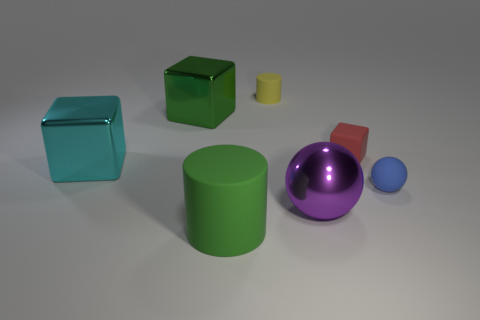Subtract all shiny blocks. How many blocks are left? 1 Add 3 small blue metal spheres. How many objects exist? 10 Subtract all balls. How many objects are left? 5 Subtract 0 brown cylinders. How many objects are left? 7 Subtract all yellow blocks. Subtract all green cylinders. How many blocks are left? 3 Subtract all brown objects. Subtract all tiny cubes. How many objects are left? 6 Add 5 large objects. How many large objects are left? 9 Add 4 large shiny spheres. How many large shiny spheres exist? 5 